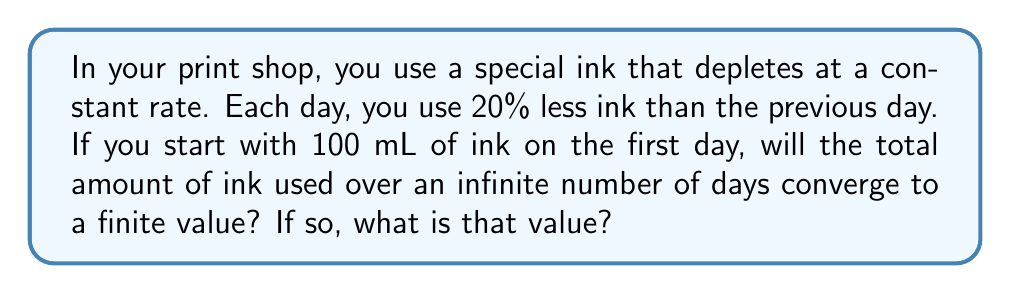Can you solve this math problem? Let's approach this step-by-step:

1) First, we need to identify this as a geometric series. The first term $a = 100$ mL, and the common ratio $r = 0.8$ (because each day uses 80% or 0.8 times the ink of the previous day).

2) The series can be written as:

   $S_{\infty} = 100 + 100(0.8) + 100(0.8)^2 + 100(0.8)^3 + ...$

3) For a geometric series to converge, the absolute value of the common ratio must be less than 1:

   $|r| < 1$

4) In this case, $|0.8| = 0.8 < 1$, so the series will converge.

5) For a convergent geometric series, the sum to infinity is given by the formula:

   $S_{\infty} = \frac{a}{1-r}$

   Where $a$ is the first term and $r$ is the common ratio.

6) Substituting our values:

   $S_{\infty} = \frac{100}{1-0.8} = \frac{100}{0.2} = 500$

Therefore, the total amount of ink used will converge to 500 mL.
Answer: Yes, converges to 500 mL 